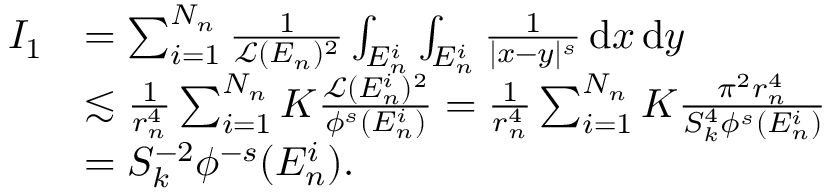<formula> <loc_0><loc_0><loc_500><loc_500>\begin{array} { r l } { I _ { 1 } } & { = \sum _ { i = 1 } ^ { N _ { n } } \frac { 1 } { \mathcal { L } ( E _ { n } ) ^ { 2 } } \int _ { E _ { n } ^ { i } } \int _ { E _ { n } ^ { i } } \frac { 1 } { | x - y | ^ { s } } \, d x \, d y } \\ & { \lesssim \frac { 1 } { r _ { n } ^ { 4 } } \sum _ { i = 1 } ^ { N _ { n } } K \frac { \mathcal { L } ( E _ { n } ^ { i } ) ^ { 2 } } { \phi ^ { s } ( E _ { n } ^ { i } ) } = \frac { 1 } { r _ { n } ^ { 4 } } \sum _ { i = 1 } ^ { N _ { n } } K \frac { \pi ^ { 2 } r _ { n } ^ { 4 } } { S _ { k } ^ { 4 } \phi ^ { s } ( E _ { n } ^ { i } ) } } \\ & { = S _ { k } ^ { - 2 } \phi ^ { - s } ( E _ { n } ^ { i } ) . } \end{array}</formula> 